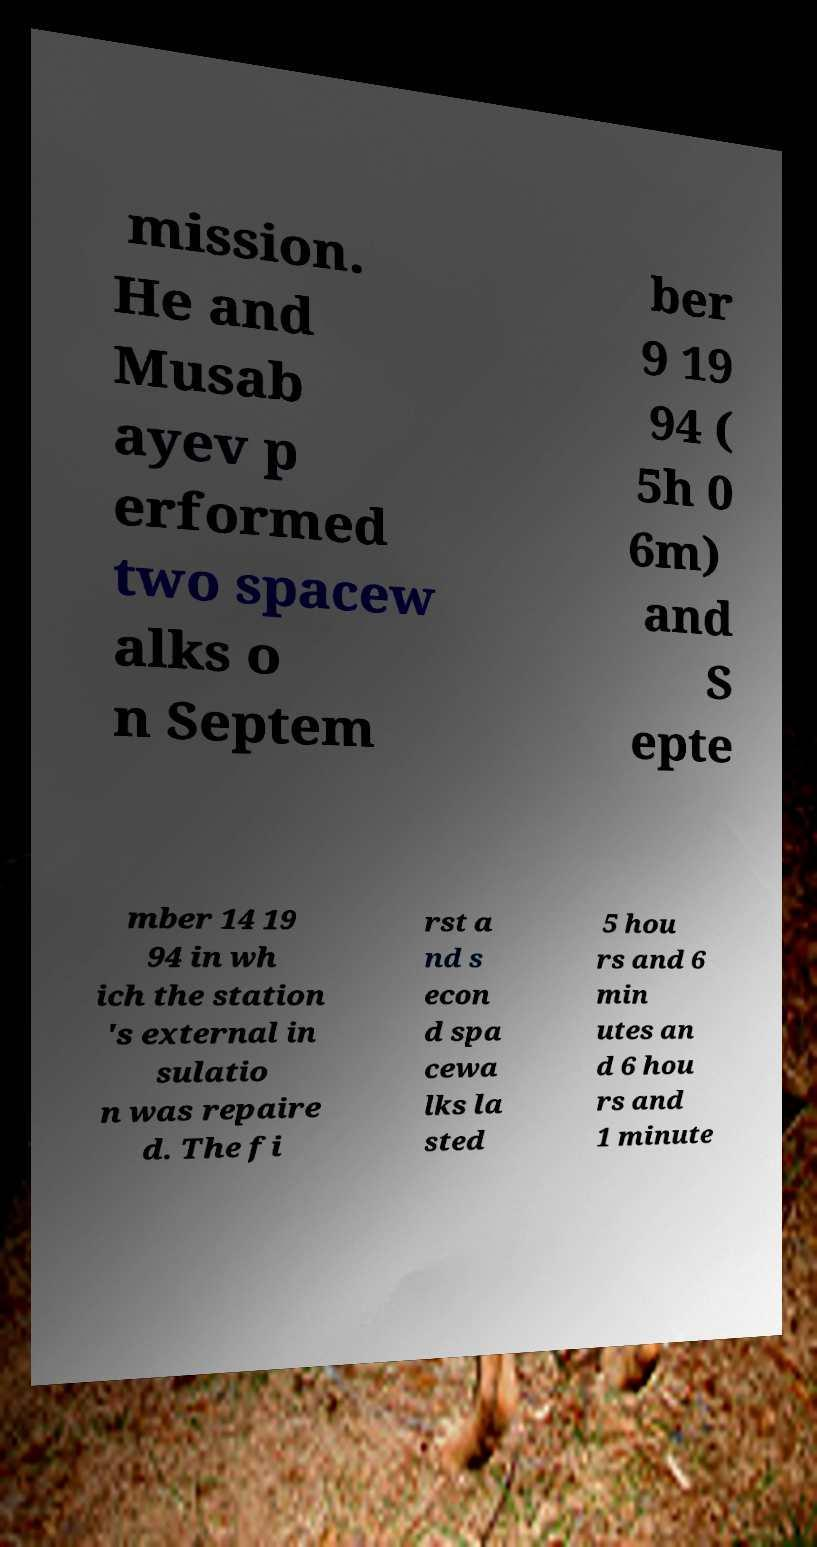Can you read and provide the text displayed in the image?This photo seems to have some interesting text. Can you extract and type it out for me? mission. He and Musab ayev p erformed two spacew alks o n Septem ber 9 19 94 ( 5h 0 6m) and S epte mber 14 19 94 in wh ich the station 's external in sulatio n was repaire d. The fi rst a nd s econ d spa cewa lks la sted 5 hou rs and 6 min utes an d 6 hou rs and 1 minute 